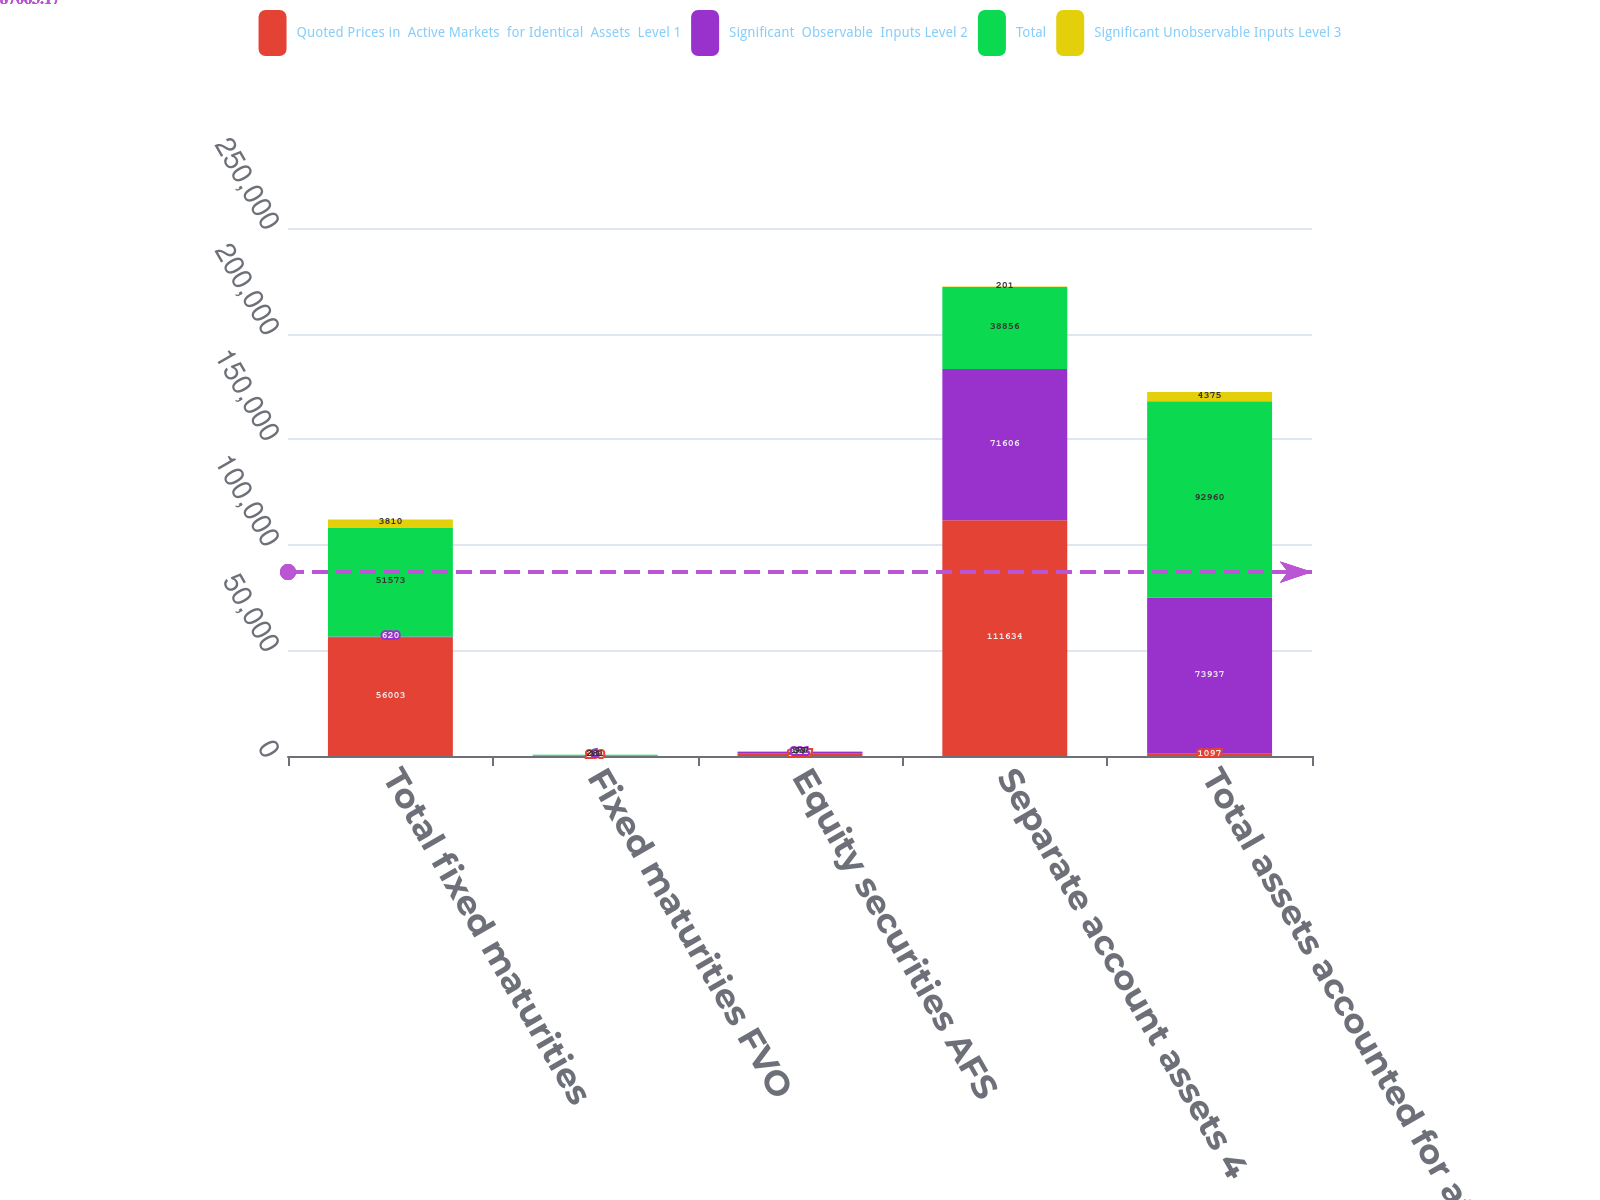Convert chart. <chart><loc_0><loc_0><loc_500><loc_500><stacked_bar_chart><ecel><fcel>Total fixed maturities<fcel>Fixed maturities FVO<fcel>Equity securities AFS<fcel>Separate account assets 4<fcel>Total assets accounted for at<nl><fcel>Quoted Prices in  Active Markets  for Identical  Assets  Level 1<fcel>56003<fcel>293<fcel>1097<fcel>111634<fcel>1097<nl><fcel>Significant  Observable  Inputs Level 2<fcel>620<fcel>1<fcel>821<fcel>71606<fcel>73937<nl><fcel>Total<fcel>51573<fcel>281<fcel>177<fcel>38856<fcel>92960<nl><fcel>Significant Unobservable Inputs Level 3<fcel>3810<fcel>11<fcel>99<fcel>201<fcel>4375<nl></chart> 